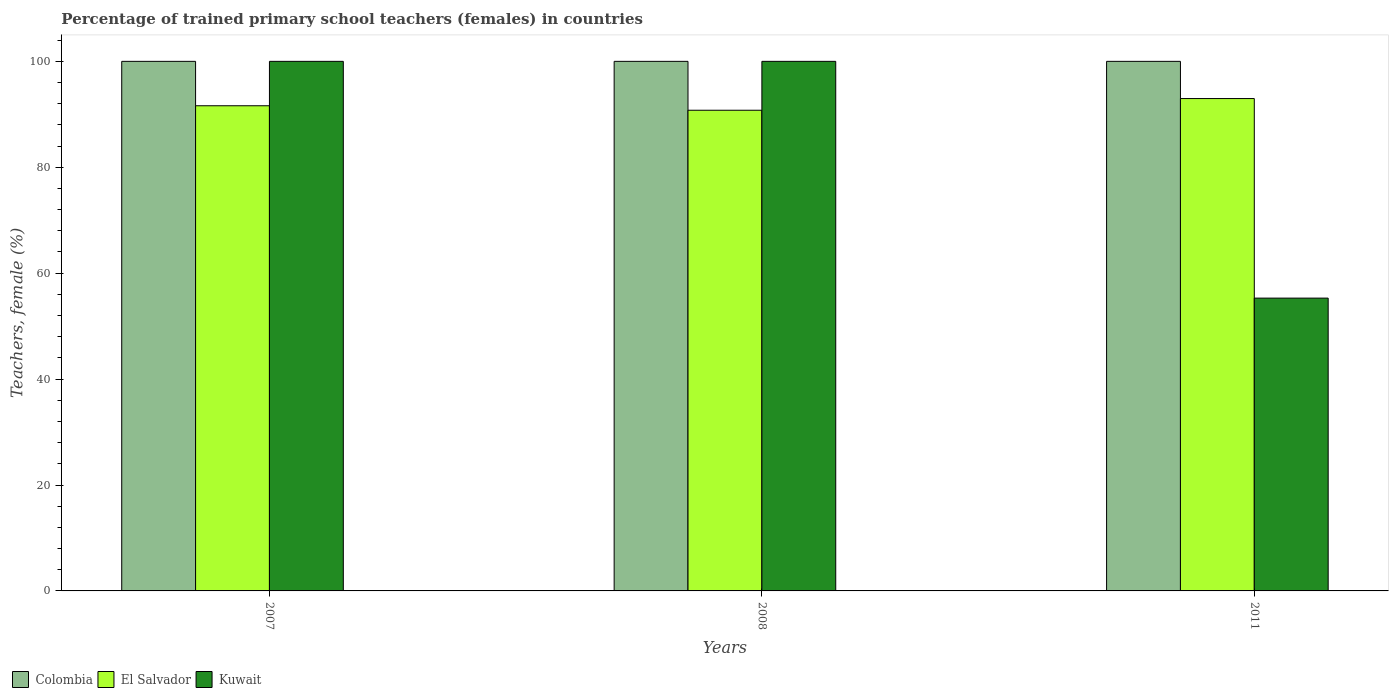How many different coloured bars are there?
Offer a terse response. 3. How many groups of bars are there?
Your answer should be compact. 3. Are the number of bars per tick equal to the number of legend labels?
Offer a terse response. Yes. Are the number of bars on each tick of the X-axis equal?
Your response must be concise. Yes. How many bars are there on the 1st tick from the left?
Offer a very short reply. 3. In how many cases, is the number of bars for a given year not equal to the number of legend labels?
Offer a terse response. 0. Across all years, what is the minimum percentage of trained primary school teachers (females) in El Salvador?
Keep it short and to the point. 90.77. In which year was the percentage of trained primary school teachers (females) in Kuwait minimum?
Ensure brevity in your answer.  2011. What is the total percentage of trained primary school teachers (females) in Colombia in the graph?
Your answer should be very brief. 300. What is the difference between the percentage of trained primary school teachers (females) in Colombia in 2007 and that in 2011?
Your response must be concise. 0. What is the difference between the percentage of trained primary school teachers (females) in Kuwait in 2008 and the percentage of trained primary school teachers (females) in Colombia in 2007?
Your answer should be compact. 0. In the year 2007, what is the difference between the percentage of trained primary school teachers (females) in El Salvador and percentage of trained primary school teachers (females) in Colombia?
Give a very brief answer. -8.38. In how many years, is the percentage of trained primary school teachers (females) in Kuwait greater than 52 %?
Give a very brief answer. 3. What is the ratio of the percentage of trained primary school teachers (females) in Kuwait in 2007 to that in 2011?
Your response must be concise. 1.81. Is the percentage of trained primary school teachers (females) in El Salvador in 2008 less than that in 2011?
Give a very brief answer. Yes. Is the difference between the percentage of trained primary school teachers (females) in El Salvador in 2007 and 2011 greater than the difference between the percentage of trained primary school teachers (females) in Colombia in 2007 and 2011?
Provide a succinct answer. No. What is the difference between the highest and the second highest percentage of trained primary school teachers (females) in El Salvador?
Your answer should be very brief. 1.36. What is the difference between the highest and the lowest percentage of trained primary school teachers (females) in Colombia?
Ensure brevity in your answer.  0. In how many years, is the percentage of trained primary school teachers (females) in El Salvador greater than the average percentage of trained primary school teachers (females) in El Salvador taken over all years?
Your answer should be very brief. 1. What does the 3rd bar from the left in 2007 represents?
Offer a terse response. Kuwait. What does the 2nd bar from the right in 2008 represents?
Provide a short and direct response. El Salvador. Are all the bars in the graph horizontal?
Provide a short and direct response. No. How many years are there in the graph?
Offer a very short reply. 3. Does the graph contain any zero values?
Keep it short and to the point. No. Where does the legend appear in the graph?
Ensure brevity in your answer.  Bottom left. How are the legend labels stacked?
Provide a short and direct response. Horizontal. What is the title of the graph?
Provide a succinct answer. Percentage of trained primary school teachers (females) in countries. What is the label or title of the Y-axis?
Provide a short and direct response. Teachers, female (%). What is the Teachers, female (%) of Colombia in 2007?
Offer a very short reply. 100. What is the Teachers, female (%) in El Salvador in 2007?
Provide a succinct answer. 91.62. What is the Teachers, female (%) in Colombia in 2008?
Your response must be concise. 100. What is the Teachers, female (%) in El Salvador in 2008?
Offer a terse response. 90.77. What is the Teachers, female (%) in El Salvador in 2011?
Offer a very short reply. 92.98. What is the Teachers, female (%) in Kuwait in 2011?
Your answer should be compact. 55.29. Across all years, what is the maximum Teachers, female (%) of Colombia?
Give a very brief answer. 100. Across all years, what is the maximum Teachers, female (%) in El Salvador?
Provide a succinct answer. 92.98. Across all years, what is the maximum Teachers, female (%) in Kuwait?
Ensure brevity in your answer.  100. Across all years, what is the minimum Teachers, female (%) of Colombia?
Offer a very short reply. 100. Across all years, what is the minimum Teachers, female (%) in El Salvador?
Provide a short and direct response. 90.77. Across all years, what is the minimum Teachers, female (%) of Kuwait?
Provide a succinct answer. 55.29. What is the total Teachers, female (%) of Colombia in the graph?
Your answer should be very brief. 300. What is the total Teachers, female (%) of El Salvador in the graph?
Your answer should be compact. 275.36. What is the total Teachers, female (%) in Kuwait in the graph?
Keep it short and to the point. 255.29. What is the difference between the Teachers, female (%) in El Salvador in 2007 and that in 2008?
Your response must be concise. 0.85. What is the difference between the Teachers, female (%) of Colombia in 2007 and that in 2011?
Ensure brevity in your answer.  0. What is the difference between the Teachers, female (%) of El Salvador in 2007 and that in 2011?
Your response must be concise. -1.36. What is the difference between the Teachers, female (%) of Kuwait in 2007 and that in 2011?
Provide a succinct answer. 44.71. What is the difference between the Teachers, female (%) of El Salvador in 2008 and that in 2011?
Provide a short and direct response. -2.21. What is the difference between the Teachers, female (%) of Kuwait in 2008 and that in 2011?
Your answer should be very brief. 44.71. What is the difference between the Teachers, female (%) in Colombia in 2007 and the Teachers, female (%) in El Salvador in 2008?
Make the answer very short. 9.23. What is the difference between the Teachers, female (%) of El Salvador in 2007 and the Teachers, female (%) of Kuwait in 2008?
Your answer should be compact. -8.38. What is the difference between the Teachers, female (%) in Colombia in 2007 and the Teachers, female (%) in El Salvador in 2011?
Provide a short and direct response. 7.02. What is the difference between the Teachers, female (%) in Colombia in 2007 and the Teachers, female (%) in Kuwait in 2011?
Keep it short and to the point. 44.71. What is the difference between the Teachers, female (%) in El Salvador in 2007 and the Teachers, female (%) in Kuwait in 2011?
Your response must be concise. 36.32. What is the difference between the Teachers, female (%) of Colombia in 2008 and the Teachers, female (%) of El Salvador in 2011?
Keep it short and to the point. 7.02. What is the difference between the Teachers, female (%) of Colombia in 2008 and the Teachers, female (%) of Kuwait in 2011?
Provide a succinct answer. 44.71. What is the difference between the Teachers, female (%) of El Salvador in 2008 and the Teachers, female (%) of Kuwait in 2011?
Give a very brief answer. 35.48. What is the average Teachers, female (%) of Colombia per year?
Your answer should be very brief. 100. What is the average Teachers, female (%) in El Salvador per year?
Ensure brevity in your answer.  91.79. What is the average Teachers, female (%) of Kuwait per year?
Your answer should be very brief. 85.1. In the year 2007, what is the difference between the Teachers, female (%) in Colombia and Teachers, female (%) in El Salvador?
Offer a very short reply. 8.38. In the year 2007, what is the difference between the Teachers, female (%) in El Salvador and Teachers, female (%) in Kuwait?
Keep it short and to the point. -8.38. In the year 2008, what is the difference between the Teachers, female (%) of Colombia and Teachers, female (%) of El Salvador?
Your answer should be compact. 9.23. In the year 2008, what is the difference between the Teachers, female (%) of El Salvador and Teachers, female (%) of Kuwait?
Your answer should be very brief. -9.23. In the year 2011, what is the difference between the Teachers, female (%) of Colombia and Teachers, female (%) of El Salvador?
Offer a very short reply. 7.02. In the year 2011, what is the difference between the Teachers, female (%) of Colombia and Teachers, female (%) of Kuwait?
Provide a short and direct response. 44.71. In the year 2011, what is the difference between the Teachers, female (%) in El Salvador and Teachers, female (%) in Kuwait?
Offer a very short reply. 37.68. What is the ratio of the Teachers, female (%) in Colombia in 2007 to that in 2008?
Your answer should be compact. 1. What is the ratio of the Teachers, female (%) of El Salvador in 2007 to that in 2008?
Ensure brevity in your answer.  1.01. What is the ratio of the Teachers, female (%) of El Salvador in 2007 to that in 2011?
Offer a terse response. 0.99. What is the ratio of the Teachers, female (%) in Kuwait in 2007 to that in 2011?
Offer a terse response. 1.81. What is the ratio of the Teachers, female (%) in Colombia in 2008 to that in 2011?
Offer a terse response. 1. What is the ratio of the Teachers, female (%) in El Salvador in 2008 to that in 2011?
Your answer should be very brief. 0.98. What is the ratio of the Teachers, female (%) in Kuwait in 2008 to that in 2011?
Offer a terse response. 1.81. What is the difference between the highest and the second highest Teachers, female (%) in Colombia?
Your answer should be very brief. 0. What is the difference between the highest and the second highest Teachers, female (%) in El Salvador?
Give a very brief answer. 1.36. What is the difference between the highest and the lowest Teachers, female (%) of El Salvador?
Your answer should be compact. 2.21. What is the difference between the highest and the lowest Teachers, female (%) of Kuwait?
Your response must be concise. 44.71. 